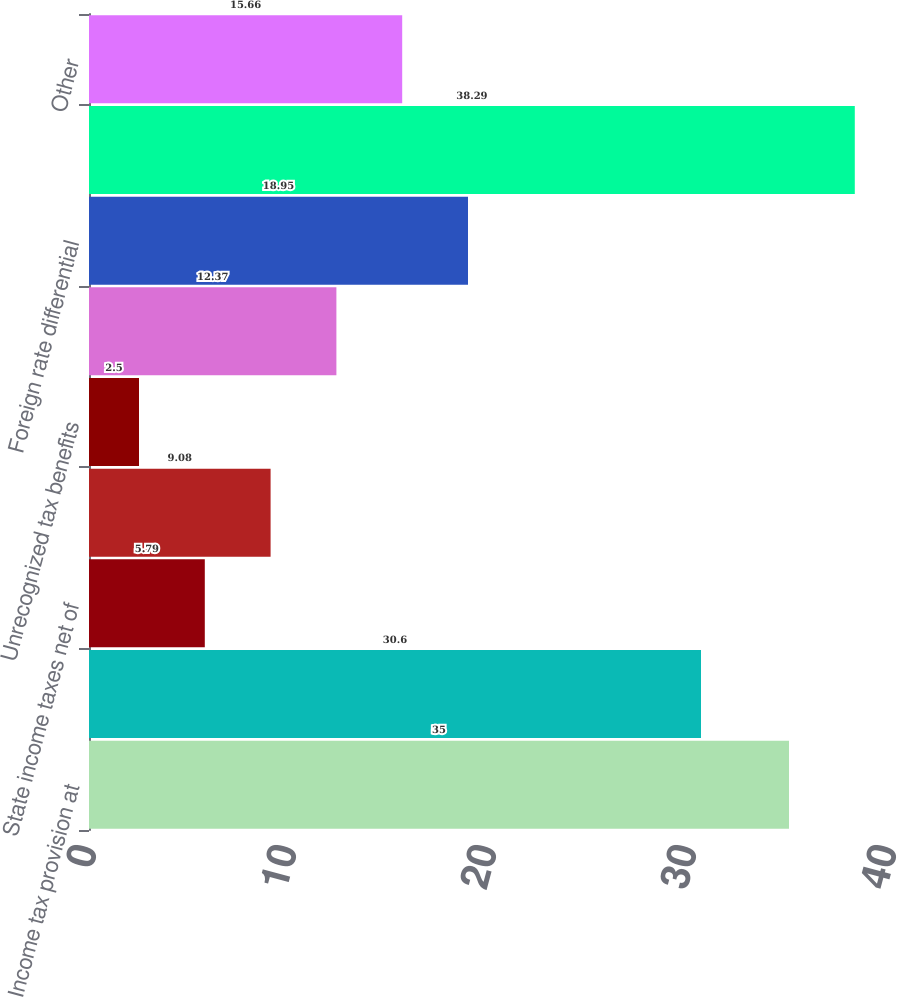Convert chart to OTSL. <chart><loc_0><loc_0><loc_500><loc_500><bar_chart><fcel>Income tax provision at<fcel>Domestic production activities<fcel>State income taxes net of<fcel>Tax credits<fcel>Unrecognized tax benefits<fcel>Non-deductible compensation<fcel>Foreign rate differential<fcel>Change in valuation allowance<fcel>Other<nl><fcel>35<fcel>30.6<fcel>5.79<fcel>9.08<fcel>2.5<fcel>12.37<fcel>18.95<fcel>38.29<fcel>15.66<nl></chart> 